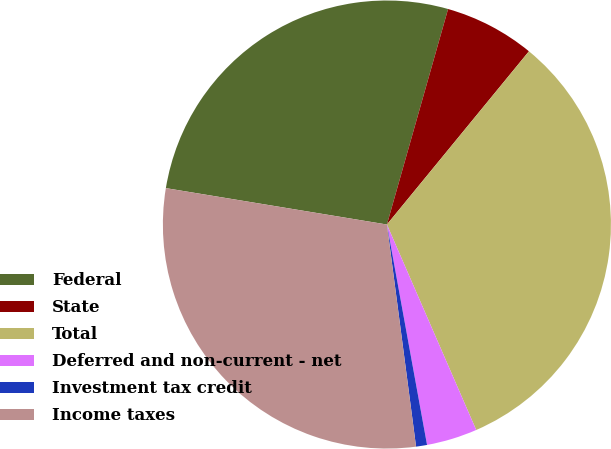Convert chart. <chart><loc_0><loc_0><loc_500><loc_500><pie_chart><fcel>Federal<fcel>State<fcel>Total<fcel>Deferred and non-current - net<fcel>Investment tax credit<fcel>Income taxes<nl><fcel>26.81%<fcel>6.53%<fcel>32.55%<fcel>3.66%<fcel>0.79%<fcel>29.68%<nl></chart> 